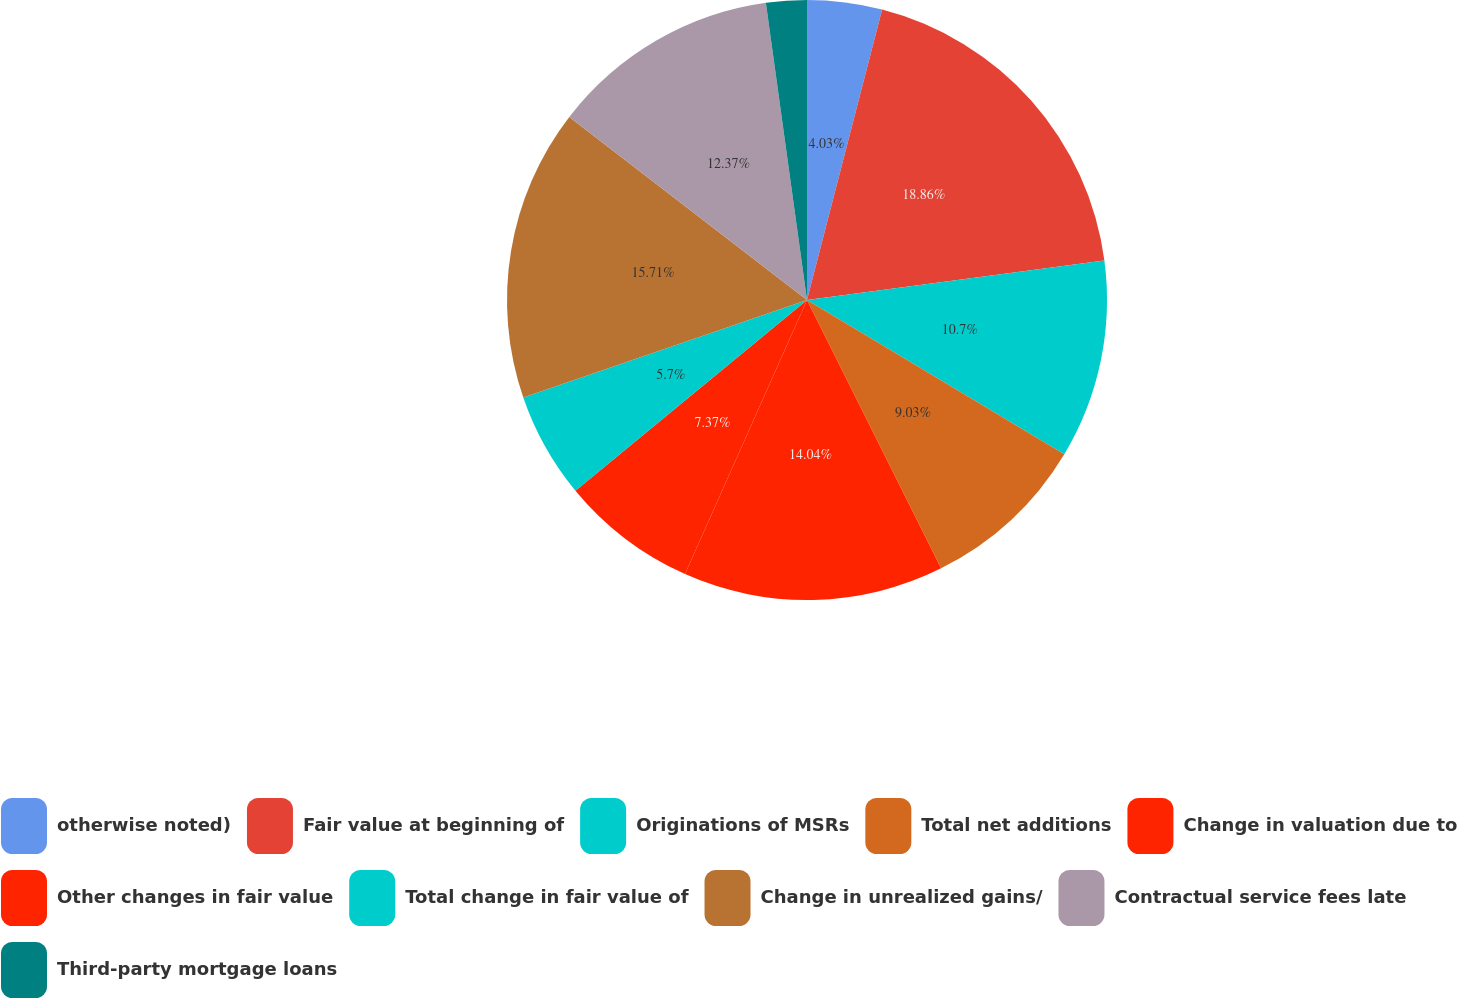Convert chart. <chart><loc_0><loc_0><loc_500><loc_500><pie_chart><fcel>otherwise noted)<fcel>Fair value at beginning of<fcel>Originations of MSRs<fcel>Total net additions<fcel>Change in valuation due to<fcel>Other changes in fair value<fcel>Total change in fair value of<fcel>Change in unrealized gains/<fcel>Contractual service fees late<fcel>Third-party mortgage loans<nl><fcel>4.03%<fcel>18.87%<fcel>10.7%<fcel>9.03%<fcel>14.04%<fcel>7.37%<fcel>5.7%<fcel>15.71%<fcel>12.37%<fcel>2.19%<nl></chart> 